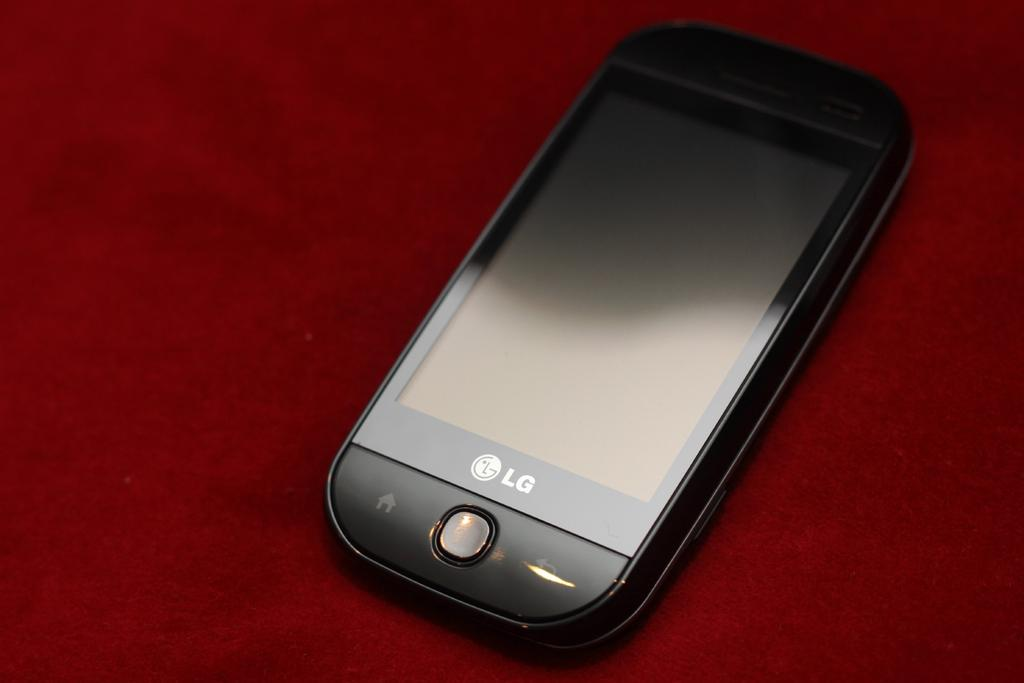<image>
Provide a brief description of the given image. An LG phone is turned off and on a red surface. 